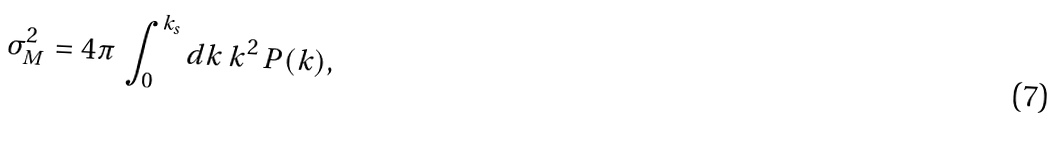<formula> <loc_0><loc_0><loc_500><loc_500>\sigma _ { M } ^ { 2 } = 4 \pi \, \int _ { 0 } ^ { k _ { s } } { d k } \, k ^ { 2 } \, P ( k ) ,</formula> 